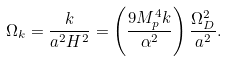<formula> <loc_0><loc_0><loc_500><loc_500>\Omega _ { k } = \frac { k } { a ^ { 2 } H ^ { 2 } } = \left ( \frac { 9 M _ { p } ^ { 4 } k } { \alpha ^ { 2 } } \right ) \frac { \Omega _ { D } ^ { 2 } } { a ^ { 2 } } .</formula> 